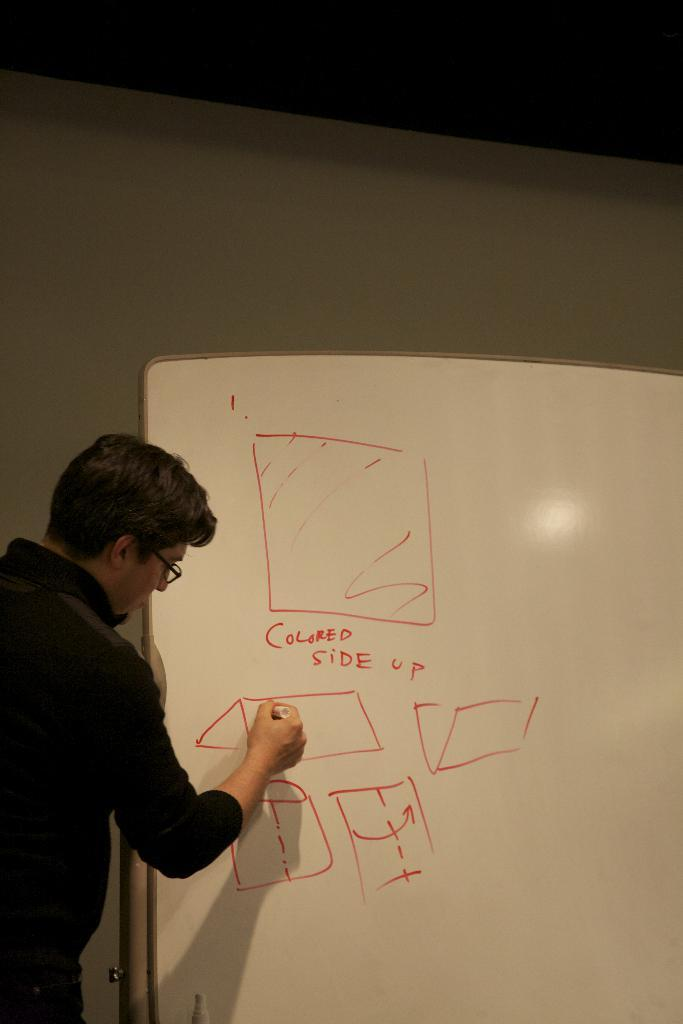<image>
Present a compact description of the photo's key features. Person drawing on a white board thato says "Colored side up". 